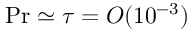Convert formula to latex. <formula><loc_0><loc_0><loc_500><loc_500>{ P r } \simeq \tau = O ( 1 0 ^ { - 3 } )</formula> 